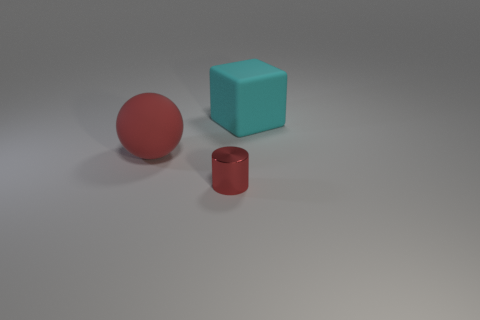How many big cyan things are the same material as the big red thing?
Your answer should be compact. 1. How many matte things are either small cylinders or brown blocks?
Your answer should be compact. 0. There is a sphere that is the same size as the cyan block; what is it made of?
Provide a short and direct response. Rubber. Are there any big cyan cubes that have the same material as the large cyan thing?
Make the answer very short. No. There is a big rubber thing to the right of the thing in front of the big object in front of the large cyan rubber object; what is its shape?
Give a very brief answer. Cube. There is a metallic object; is it the same size as the rubber thing that is to the right of the large red sphere?
Your answer should be compact. No. There is a thing that is both on the right side of the matte ball and left of the big rubber cube; what shape is it?
Your answer should be compact. Cylinder. What number of small things are rubber objects or metallic cylinders?
Provide a succinct answer. 1. Is the number of rubber things that are to the left of the large matte block the same as the number of red shiny things that are on the left side of the red shiny thing?
Make the answer very short. No. What number of other objects are there of the same color as the big block?
Your response must be concise. 0. 